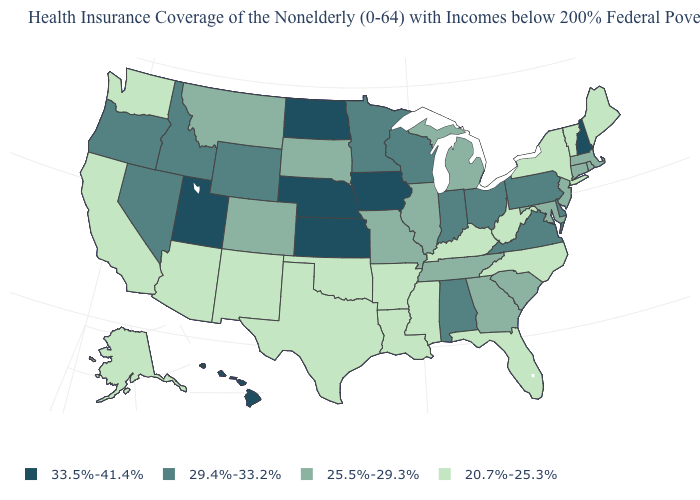What is the value of Pennsylvania?
Write a very short answer. 29.4%-33.2%. What is the value of Rhode Island?
Short answer required. 25.5%-29.3%. What is the value of Alaska?
Answer briefly. 20.7%-25.3%. What is the value of Alabama?
Concise answer only. 29.4%-33.2%. What is the highest value in states that border Maine?
Keep it brief. 33.5%-41.4%. Which states have the highest value in the USA?
Give a very brief answer. Hawaii, Iowa, Kansas, Nebraska, New Hampshire, North Dakota, Utah. Which states have the lowest value in the USA?
Be succinct. Alaska, Arizona, Arkansas, California, Florida, Kentucky, Louisiana, Maine, Mississippi, New Mexico, New York, North Carolina, Oklahoma, Texas, Vermont, Washington, West Virginia. Name the states that have a value in the range 20.7%-25.3%?
Answer briefly. Alaska, Arizona, Arkansas, California, Florida, Kentucky, Louisiana, Maine, Mississippi, New Mexico, New York, North Carolina, Oklahoma, Texas, Vermont, Washington, West Virginia. Which states have the lowest value in the Northeast?
Be succinct. Maine, New York, Vermont. What is the value of Illinois?
Concise answer only. 25.5%-29.3%. Does Wyoming have a lower value than Alaska?
Concise answer only. No. Among the states that border North Carolina , does Virginia have the highest value?
Give a very brief answer. Yes. Which states have the lowest value in the West?
Be succinct. Alaska, Arizona, California, New Mexico, Washington. Which states have the highest value in the USA?
Write a very short answer. Hawaii, Iowa, Kansas, Nebraska, New Hampshire, North Dakota, Utah. What is the lowest value in states that border Oregon?
Quick response, please. 20.7%-25.3%. 